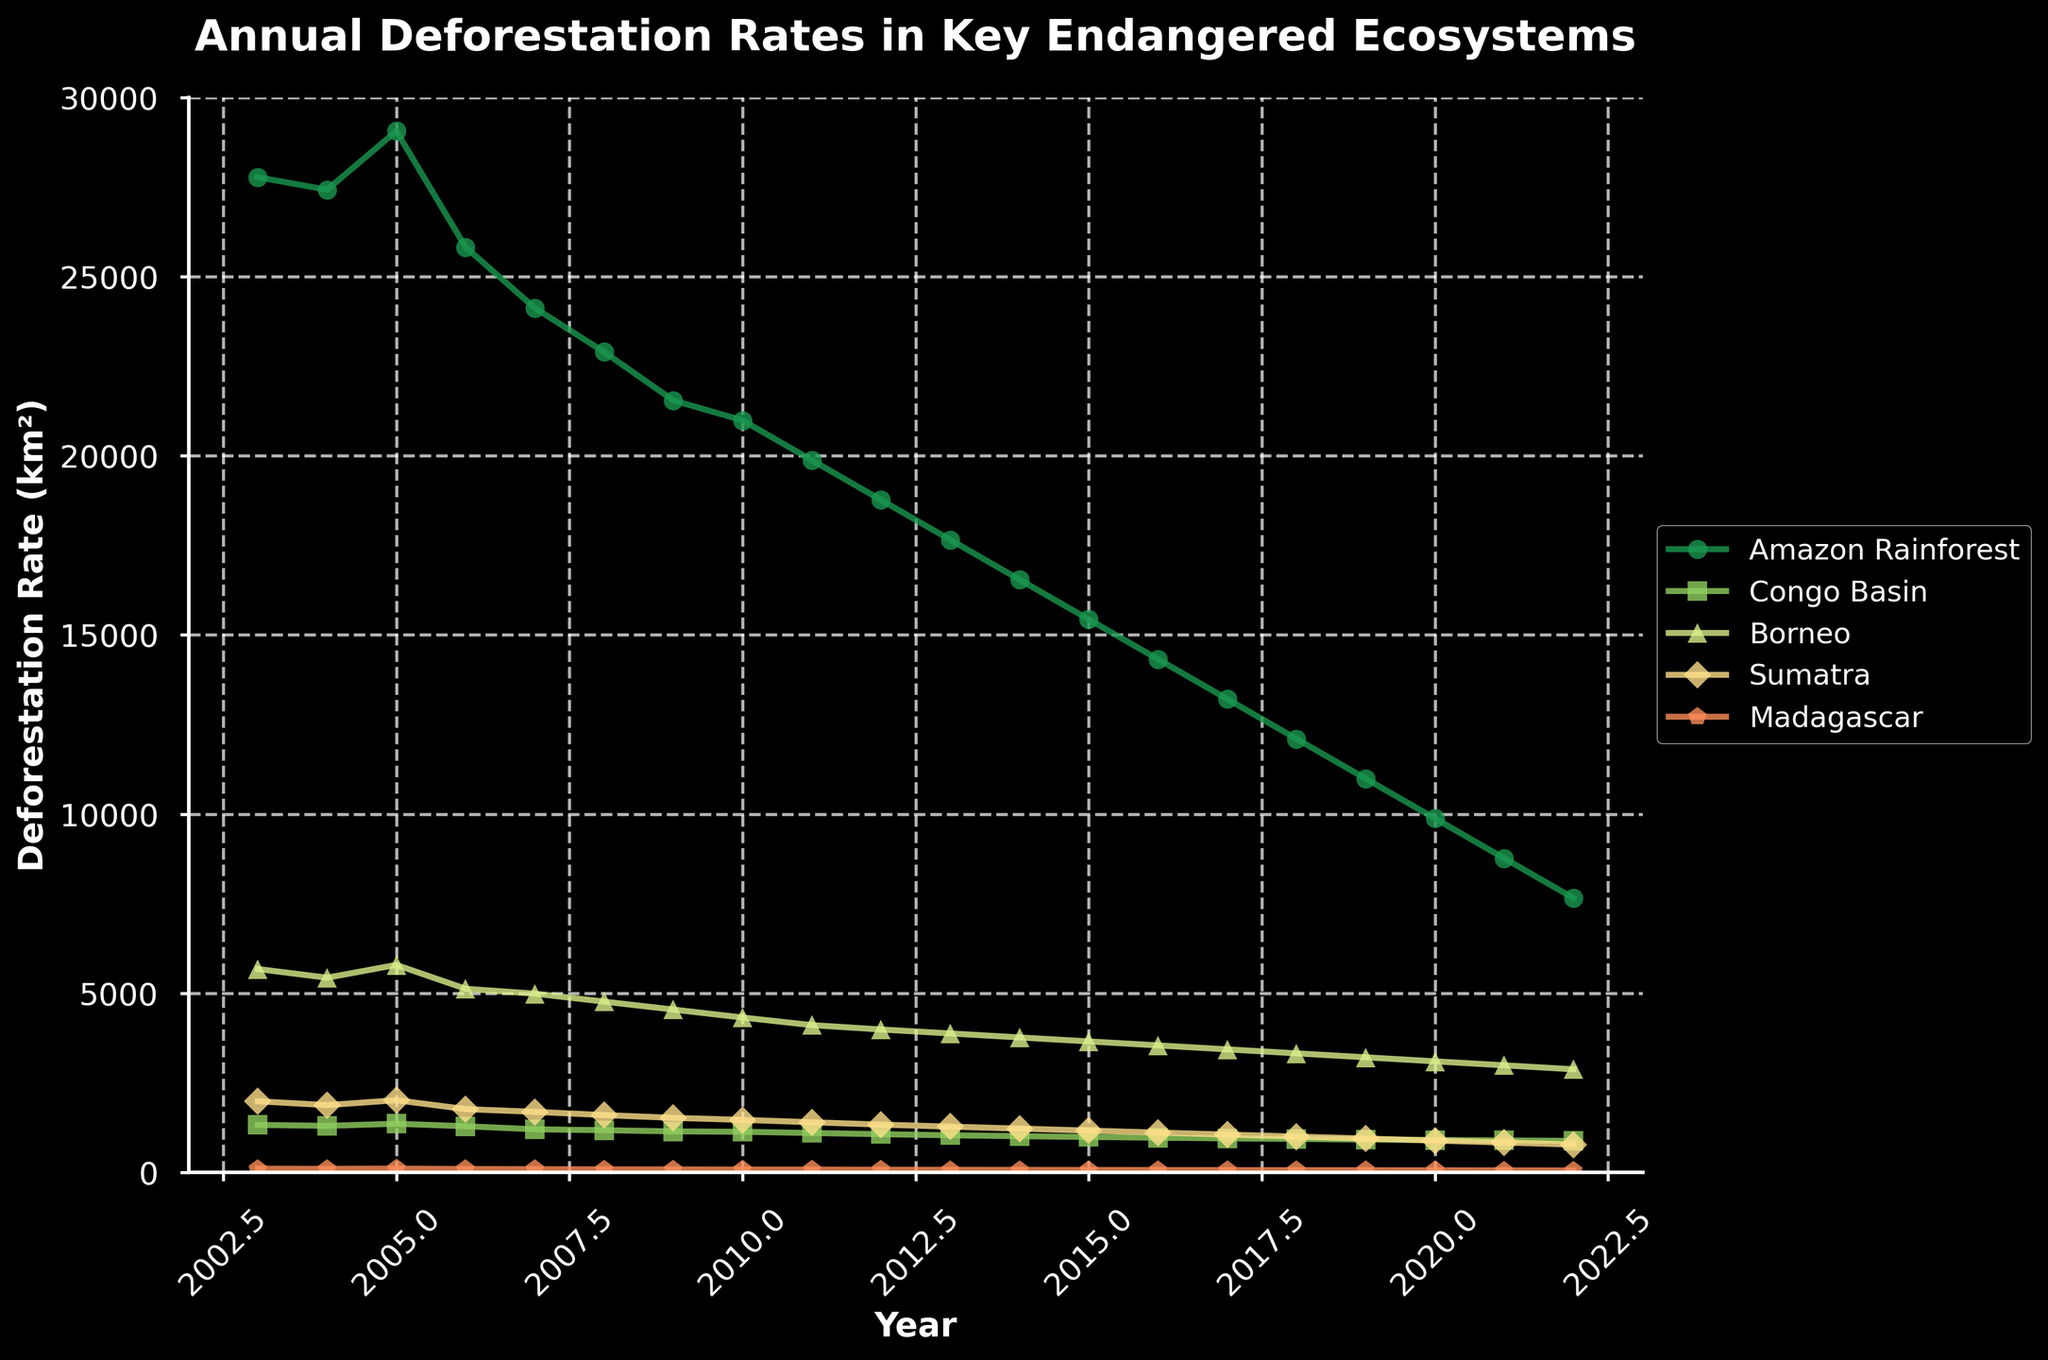What is the trend in the deforestation rate of the Amazon Rainforest over the 20-year period? The deforestation rate of the Amazon Rainforest shows a general downward trend from 2003 to 2022, starting at 27,772 km² in 2003 and decreasing to 7,654 km² in 2022.
Answer: Downward trend Which ecosystem had the highest deforestation rate in 2015? Observing the data points for 2015, the Amazon Rainforest had the highest deforestation rate with 15,432 km² compared to the Congo Basin (987 km²), Borneo (3,654 km²), Sumatra (1,165 km²), and Madagascar (67 km²).
Answer: Amazon Rainforest What is the difference in the deforestation rate of the Congo Basin between 2003 and 2022? The deforestation rate of the Congo Basin was 1,324 km² in 2003 and 878 km² in 2022. The difference is calculated as 1,324 km² - 878 km².
Answer: 446 km² How does the deforestation rate of Madagascar in 2010 compare to that in 2020? In 2010, Madagascar's deforestation rate was 79 km², and in 2020, it was 57 km². Comparing these values, 79 km² is higher than 57 km².
Answer: Higher in 2010 Which ecosystem experienced the lowest deforestation rate in 2007 and what was the rate? Referring to the data for 2007, Madagascar had the lowest deforestation rate at 89 km².
Answer: Madagascar, 89 km² Calculate the average annual deforestation rate of Sumatra from 2010 to 2020. The deforestation rates for Sumatra from 2010 to 2020 are: 1,465, 1,398, 1,332, 1,276, 1,221, 1,165, 1,109, 1,054, 998, 943, and 887. Their sum is 12,848, and the average is 12,848 / 11.
Answer: 1,168 km² Compare the deforestation rates of Borneo and Sumatra in 2009. Which one was higher and by how much? In 2009, Borneo's deforestation rate was 4,543 km², and Sumatra's was 1,521 km². The difference is 4,543 km² - 1,521 km².
Answer: Borneo by 3,022 km² What is the overall percentage decrease in the deforestation rate of the Amazon Rainforest from 2003 to 2022? The deforestation rate in 2003 was 27,772 km², and in 2022 it was 7,654 km². The change is (27,772 - 7,654) / 27,772 * 100%.
Answer: Approximately 72.45% What year did the Amazon Rainforest first drop below a deforestation rate of 20,000 km²? Viewing the data for the Amazon Rainforest, it first dropped below 20,000 km² in 2011 with a rate of 19,876 km².
Answer: 2011 